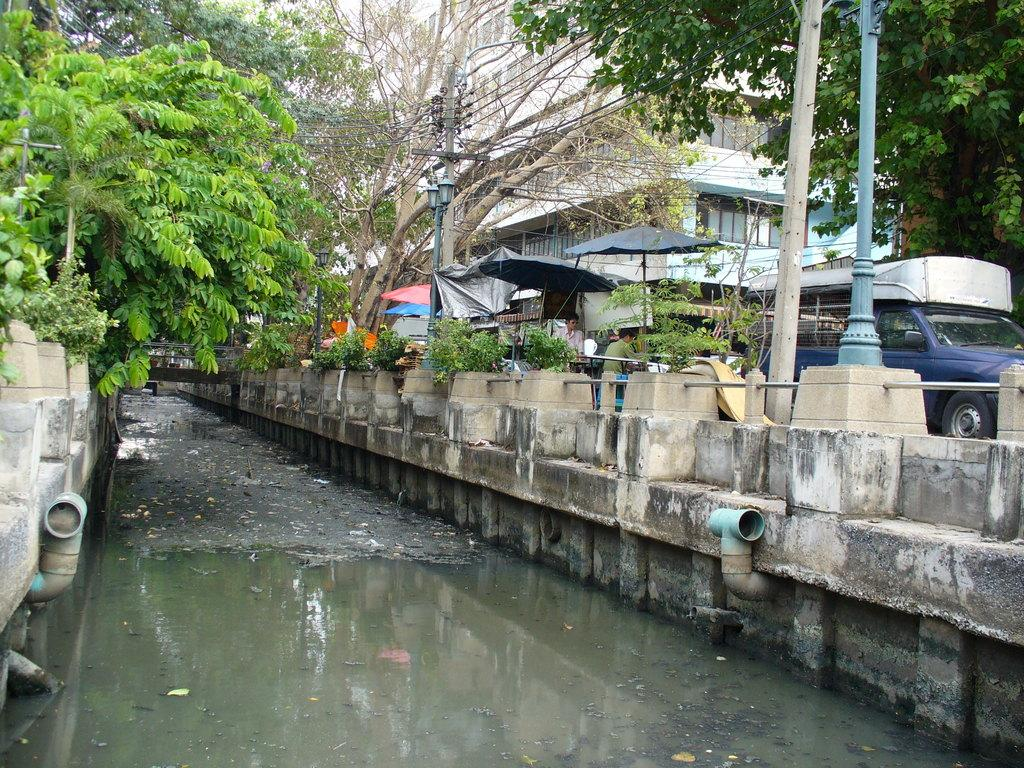What is the primary element visible in the image? There is water in the image. What can be seen in the foreground area of the image? There are boundaries in the foreground area of the image. What is visible in the background of the image? There are trees, people, vehicles, stalls, poles, and buildings in the background of the image. What type of lunch is being exchanged between the achievers in the image? There is no lunch or achievers present in the image; it features water, boundaries, and various elements in the background. 